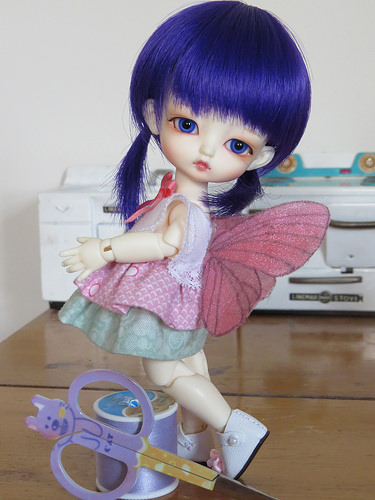<image>
Is the wing on the doll? Yes. Looking at the image, I can see the wing is positioned on top of the doll, with the doll providing support. 